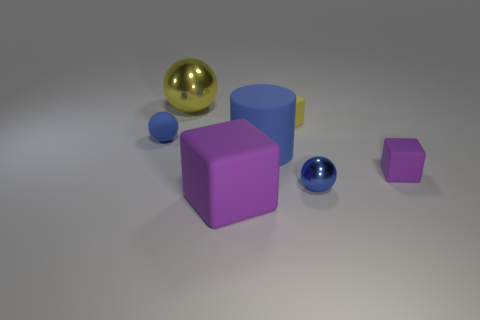There is a big rubber cube in front of the block behind the large matte cylinder; how many purple rubber blocks are right of it?
Provide a short and direct response. 1. Are there an equal number of small blue things that are left of the yellow shiny thing and purple rubber objects?
Your answer should be very brief. No. How many spheres are small cyan matte things or big objects?
Provide a short and direct response. 1. Is the color of the big metal thing the same as the rubber sphere?
Your response must be concise. No. Are there the same number of large purple matte objects that are left of the big blue thing and yellow matte blocks in front of the big purple block?
Your answer should be very brief. No. What color is the matte sphere?
Provide a short and direct response. Blue. How many objects are either tiny spheres on the right side of the tiny blue matte object or blue matte objects?
Your response must be concise. 3. There is a metallic thing that is in front of the large yellow sphere; is its size the same as the cube left of the yellow matte thing?
Your answer should be very brief. No. Is there any other thing that has the same material as the tiny purple thing?
Your response must be concise. Yes. What number of things are either small objects that are to the left of the yellow metallic ball or blue balls that are in front of the cylinder?
Give a very brief answer. 2. 